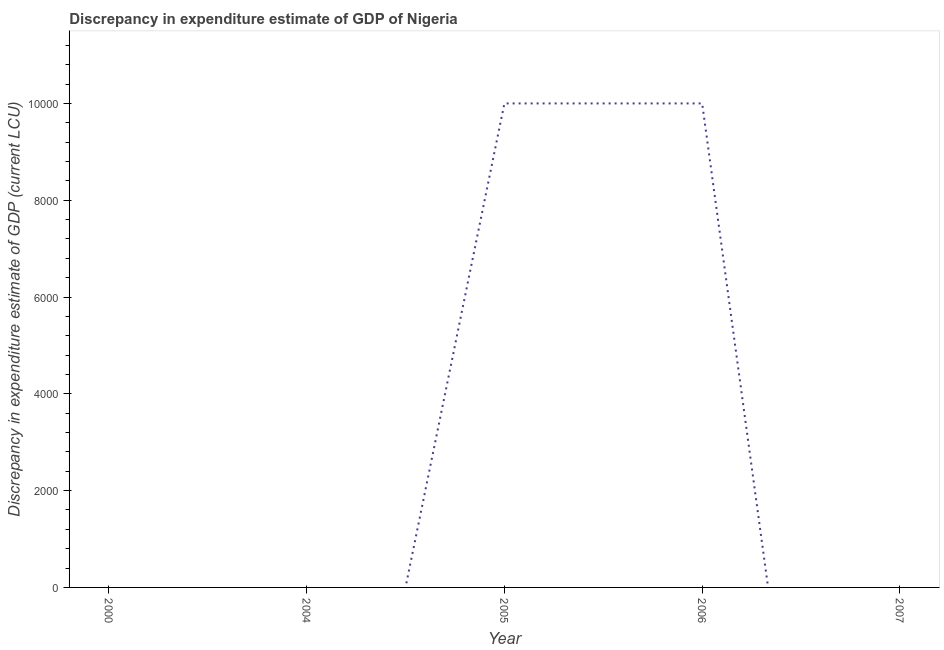What is the discrepancy in expenditure estimate of gdp in 2006?
Keep it short and to the point. 10000. Across all years, what is the minimum discrepancy in expenditure estimate of gdp?
Your answer should be compact. 0. In which year was the discrepancy in expenditure estimate of gdp maximum?
Keep it short and to the point. 2005. What is the average discrepancy in expenditure estimate of gdp per year?
Your response must be concise. 4000. What is the ratio of the discrepancy in expenditure estimate of gdp in 2005 to that in 2006?
Provide a succinct answer. 1. Is the difference between the discrepancy in expenditure estimate of gdp in 2005 and 2006 greater than the difference between any two years?
Your response must be concise. No. Does the graph contain any zero values?
Your answer should be very brief. Yes. What is the title of the graph?
Offer a terse response. Discrepancy in expenditure estimate of GDP of Nigeria. What is the label or title of the Y-axis?
Make the answer very short. Discrepancy in expenditure estimate of GDP (current LCU). What is the Discrepancy in expenditure estimate of GDP (current LCU) in 2004?
Offer a terse response. 0. What is the Discrepancy in expenditure estimate of GDP (current LCU) of 2005?
Your answer should be very brief. 10000. What is the Discrepancy in expenditure estimate of GDP (current LCU) in 2006?
Ensure brevity in your answer.  10000. What is the difference between the Discrepancy in expenditure estimate of GDP (current LCU) in 2005 and 2006?
Keep it short and to the point. 0. 